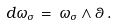<formula> <loc_0><loc_0><loc_500><loc_500>d \omega _ { \sigma } \, = \, \omega _ { \sigma } \wedge \theta \, .</formula> 